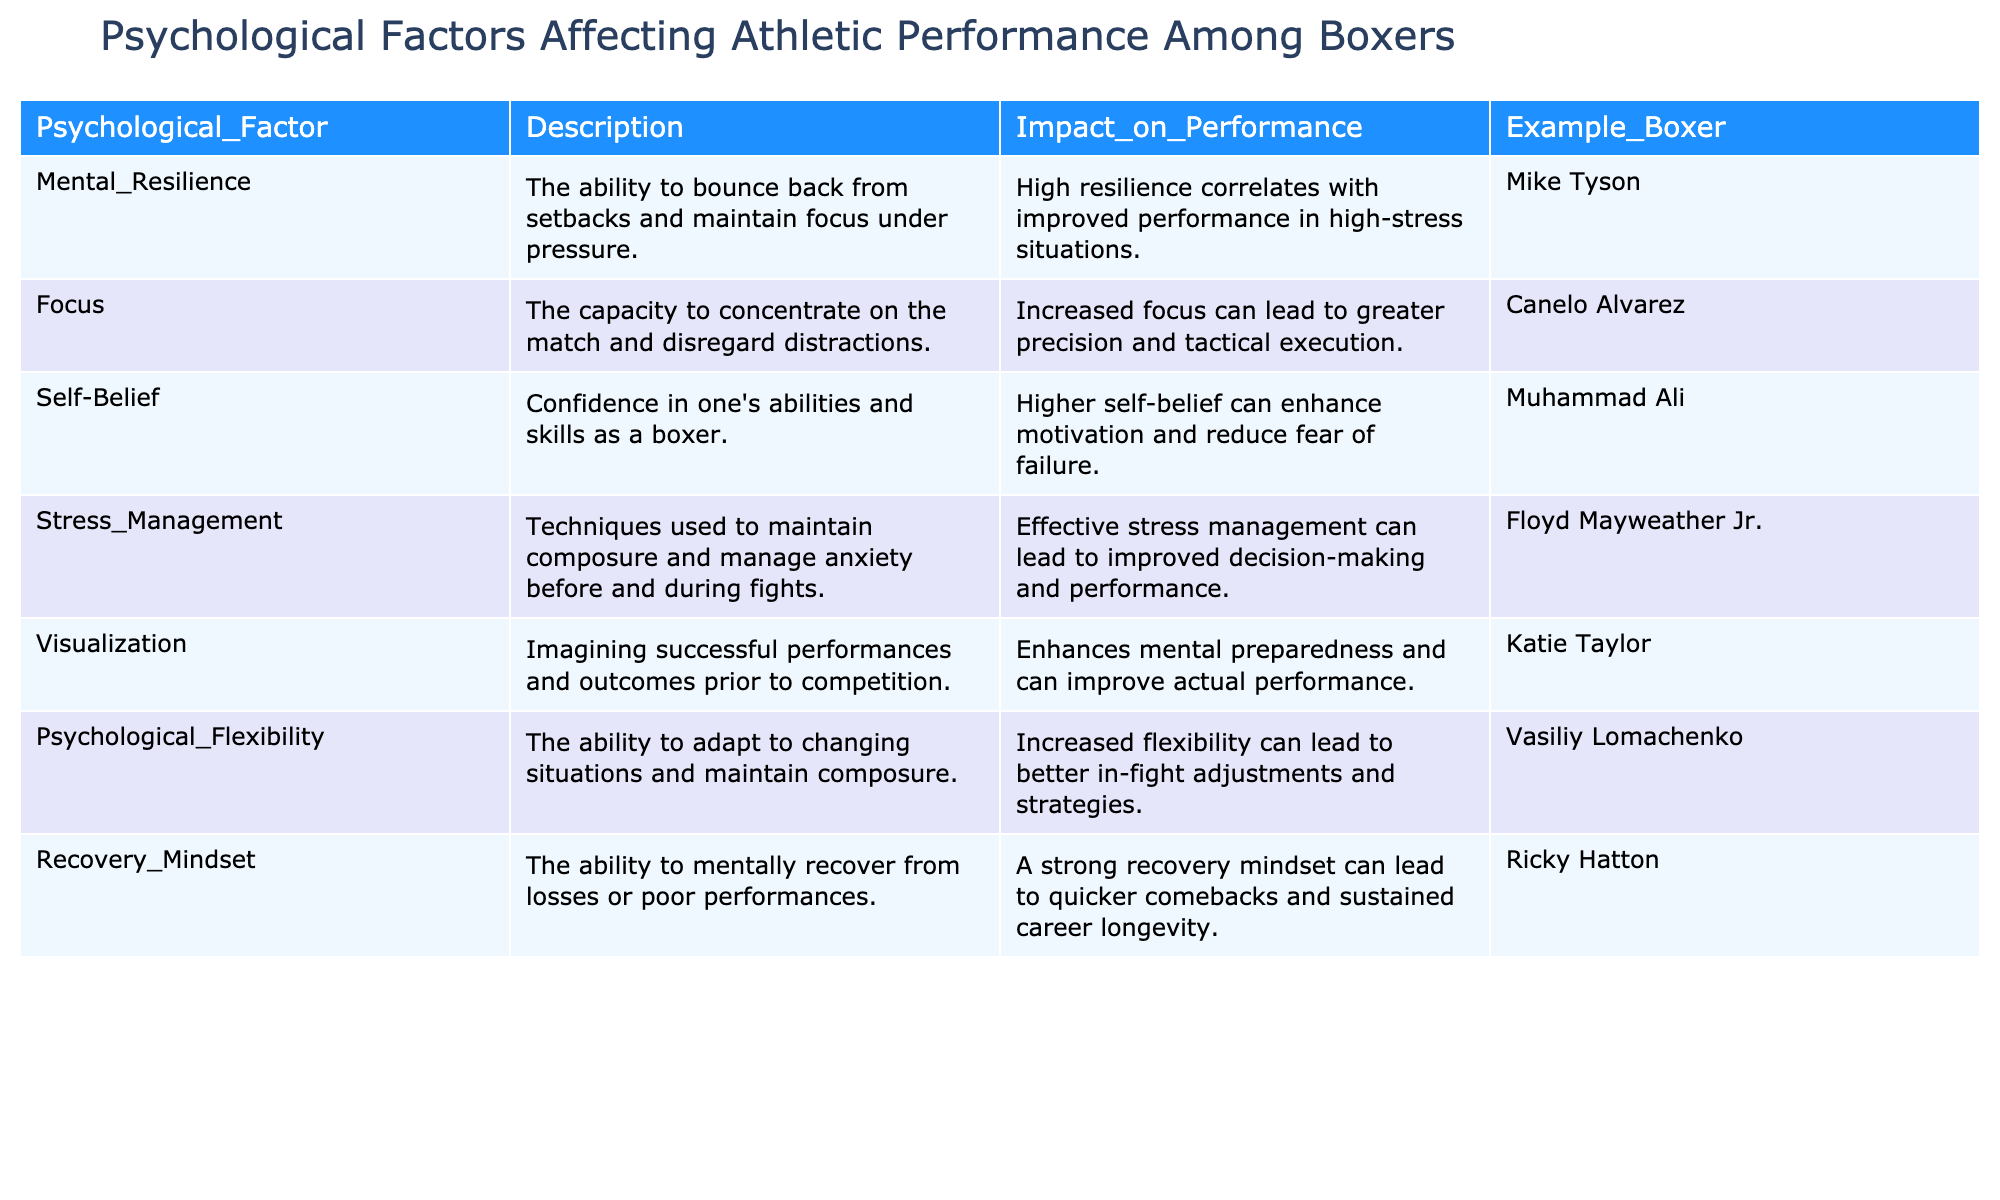What psychological factor is associated with Mike Tyson? The table lists Mike Tyson under the "Mental Resilience" psychological factor. This means his ability to bounce back from setbacks and maintain focus under pressure is highlighted.
Answer: Mental Resilience Which boxer is known for their stress management techniques? According to the table, Floyd Mayweather Jr. is listed under "Stress Management," indicating he is recognized for his techniques to maintain composure and manage anxiety before and during fights.
Answer: Floyd Mayweather Jr How many psychological factors are mentioned in the table? The table outlines 7 psychological factors affecting athletic performance among boxers, as seen in the rows listed in the data. Count each unique entry in the "Psychological_Factor" column to arrive at the total.
Answer: 7 Which factor correlates with improved decision-making and performance? The factor of "Stress Management" correlates with improved decision-making and performance, as stated in the Description column in the table.
Answer: Stress Management Is self-belief a psychological factor that can enhance a boxer's motivation? Yes, the table indicates that higher self-belief can enhance motivation and reduce fear of failure, confirming that self-belief is indeed a psychological factor that contributes positively.
Answer: Yes What is the commonality between Canelo Alvarez and visualization? Canelo Alvarez is listed under the "Focus" factor, and although he is not directly linked to visualization, both focus and visualization are psychological factors that can improve athletic performance. Focus enhances tactical execution, while visualization enhances mental preparedness. Thus, they share a common goal of improving performance in boxing.
Answer: Both improve performance Which boxer demonstrates psychological flexibility and what is its importance? Vasiliy Lomachenko demonstrates "Psychological Flexibility," which is important as it allows better in-fight adjustments and strategies according to the table's description.
Answer: Vasiliy Lomachenko What impact does a recovery mindset have on a boxer's career longevity? The table notes that a strong recovery mindset can lead to quicker comebacks and sustained career longevity, suggesting that maintaining mental resilience after losses is crucial for a boxer’s ongoing success.
Answer: Quicker comebacks and sustained career longevity Which psychological factor is linked to improved performance through mental preparedness? "Visualization" is linked to improved performance through mental preparedness, as indicated within the Description column associated with Katie Taylor in the Example_Boxer section of the table.
Answer: Visualization 